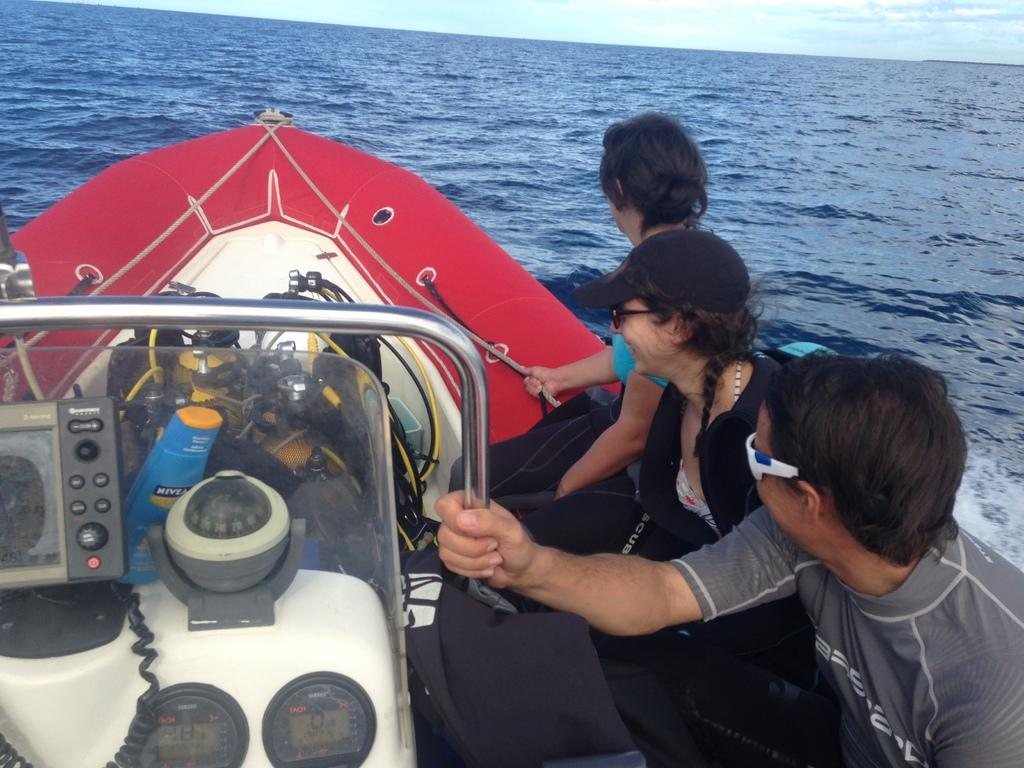How many people are in the image? There are three people in the image. What are the people doing in the image? The people are sitting on a boat. Where is the boat located in the image? The boat is on the water. What can be seen in the background of the image? The sky is visible in the image. What type of exchange is taking place between the people on the boat? There is no exchange taking place between the people on the boat in the image. What memories are the people on the boat recalling? There is no indication of any memories being recalled in the image. 